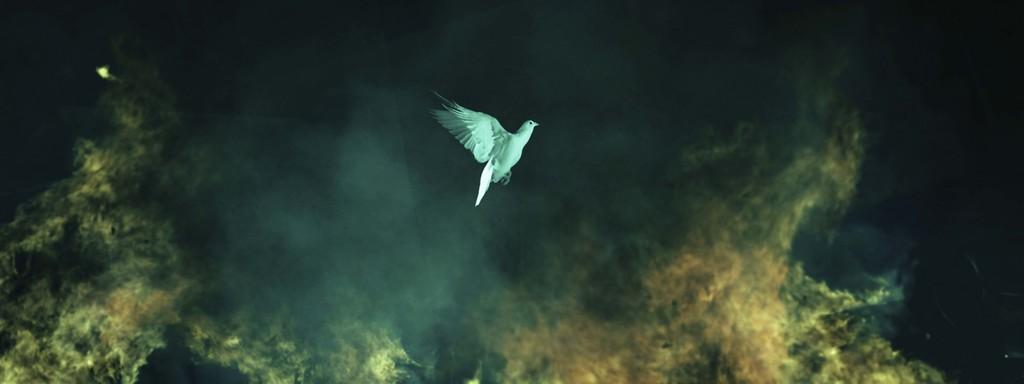What is the main subject of the image? The main subject of the image is a bird flying. What can be seen in the background of the image? There is fire and smoke visible in the background of the image. What type of structure can be seen in the aftermath of the fire in the image? There is no structure present in the image; it features a bird flying with fire and smoke in the background. 